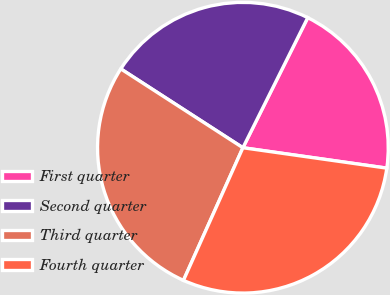Convert chart to OTSL. <chart><loc_0><loc_0><loc_500><loc_500><pie_chart><fcel>First quarter<fcel>Second quarter<fcel>Third quarter<fcel>Fourth quarter<nl><fcel>19.88%<fcel>23.23%<fcel>27.42%<fcel>29.46%<nl></chart> 